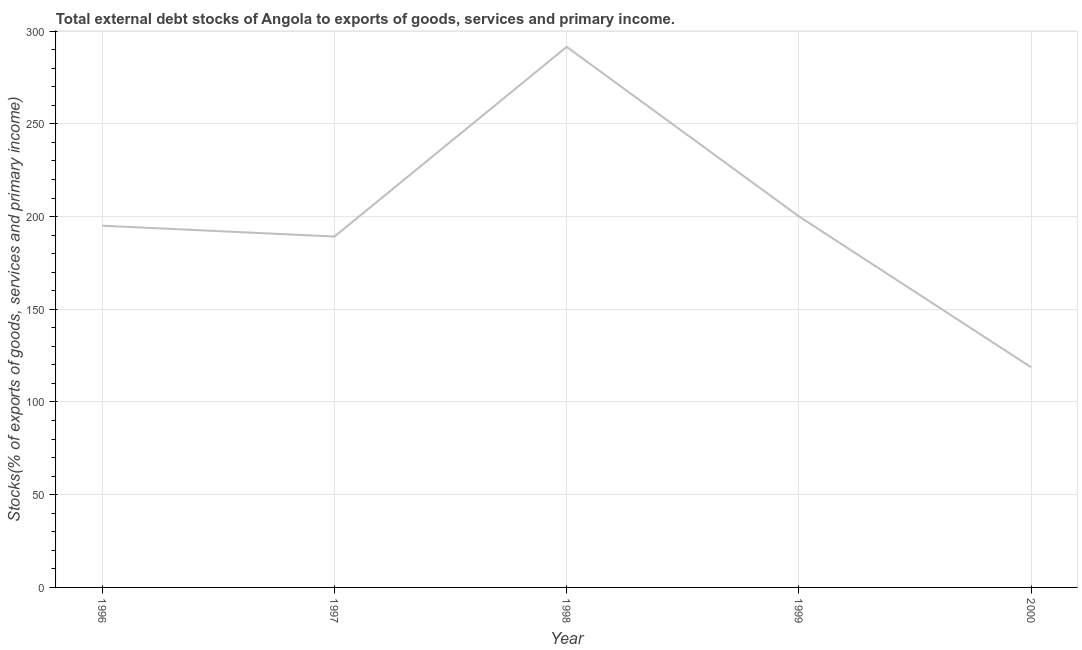What is the external debt stocks in 1996?
Provide a short and direct response. 195.08. Across all years, what is the maximum external debt stocks?
Keep it short and to the point. 291.53. Across all years, what is the minimum external debt stocks?
Your answer should be compact. 118.74. In which year was the external debt stocks minimum?
Your answer should be compact. 2000. What is the sum of the external debt stocks?
Ensure brevity in your answer.  994.68. What is the difference between the external debt stocks in 1996 and 1999?
Your answer should be compact. -5.04. What is the average external debt stocks per year?
Ensure brevity in your answer.  198.94. What is the median external debt stocks?
Keep it short and to the point. 195.08. In how many years, is the external debt stocks greater than 50 %?
Give a very brief answer. 5. Do a majority of the years between 1997 and 2000 (inclusive) have external debt stocks greater than 170 %?
Keep it short and to the point. Yes. What is the ratio of the external debt stocks in 1996 to that in 1999?
Provide a short and direct response. 0.97. Is the external debt stocks in 1996 less than that in 1999?
Offer a terse response. Yes. Is the difference between the external debt stocks in 1996 and 1998 greater than the difference between any two years?
Offer a terse response. No. What is the difference between the highest and the second highest external debt stocks?
Your answer should be very brief. 91.42. What is the difference between the highest and the lowest external debt stocks?
Your answer should be compact. 172.78. Does the external debt stocks monotonically increase over the years?
Offer a terse response. No. What is the difference between two consecutive major ticks on the Y-axis?
Offer a very short reply. 50. Does the graph contain grids?
Provide a succinct answer. Yes. What is the title of the graph?
Your answer should be compact. Total external debt stocks of Angola to exports of goods, services and primary income. What is the label or title of the Y-axis?
Provide a short and direct response. Stocks(% of exports of goods, services and primary income). What is the Stocks(% of exports of goods, services and primary income) in 1996?
Make the answer very short. 195.08. What is the Stocks(% of exports of goods, services and primary income) of 1997?
Your response must be concise. 189.22. What is the Stocks(% of exports of goods, services and primary income) in 1998?
Your response must be concise. 291.53. What is the Stocks(% of exports of goods, services and primary income) of 1999?
Make the answer very short. 200.11. What is the Stocks(% of exports of goods, services and primary income) in 2000?
Your response must be concise. 118.74. What is the difference between the Stocks(% of exports of goods, services and primary income) in 1996 and 1997?
Give a very brief answer. 5.85. What is the difference between the Stocks(% of exports of goods, services and primary income) in 1996 and 1998?
Give a very brief answer. -96.45. What is the difference between the Stocks(% of exports of goods, services and primary income) in 1996 and 1999?
Ensure brevity in your answer.  -5.04. What is the difference between the Stocks(% of exports of goods, services and primary income) in 1996 and 2000?
Keep it short and to the point. 76.33. What is the difference between the Stocks(% of exports of goods, services and primary income) in 1997 and 1998?
Your answer should be compact. -102.3. What is the difference between the Stocks(% of exports of goods, services and primary income) in 1997 and 1999?
Your response must be concise. -10.89. What is the difference between the Stocks(% of exports of goods, services and primary income) in 1997 and 2000?
Make the answer very short. 70.48. What is the difference between the Stocks(% of exports of goods, services and primary income) in 1998 and 1999?
Your answer should be very brief. 91.42. What is the difference between the Stocks(% of exports of goods, services and primary income) in 1998 and 2000?
Make the answer very short. 172.78. What is the difference between the Stocks(% of exports of goods, services and primary income) in 1999 and 2000?
Provide a succinct answer. 81.37. What is the ratio of the Stocks(% of exports of goods, services and primary income) in 1996 to that in 1997?
Provide a succinct answer. 1.03. What is the ratio of the Stocks(% of exports of goods, services and primary income) in 1996 to that in 1998?
Keep it short and to the point. 0.67. What is the ratio of the Stocks(% of exports of goods, services and primary income) in 1996 to that in 1999?
Provide a succinct answer. 0.97. What is the ratio of the Stocks(% of exports of goods, services and primary income) in 1996 to that in 2000?
Provide a short and direct response. 1.64. What is the ratio of the Stocks(% of exports of goods, services and primary income) in 1997 to that in 1998?
Your response must be concise. 0.65. What is the ratio of the Stocks(% of exports of goods, services and primary income) in 1997 to that in 1999?
Keep it short and to the point. 0.95. What is the ratio of the Stocks(% of exports of goods, services and primary income) in 1997 to that in 2000?
Offer a terse response. 1.59. What is the ratio of the Stocks(% of exports of goods, services and primary income) in 1998 to that in 1999?
Your answer should be very brief. 1.46. What is the ratio of the Stocks(% of exports of goods, services and primary income) in 1998 to that in 2000?
Provide a short and direct response. 2.46. What is the ratio of the Stocks(% of exports of goods, services and primary income) in 1999 to that in 2000?
Provide a succinct answer. 1.69. 